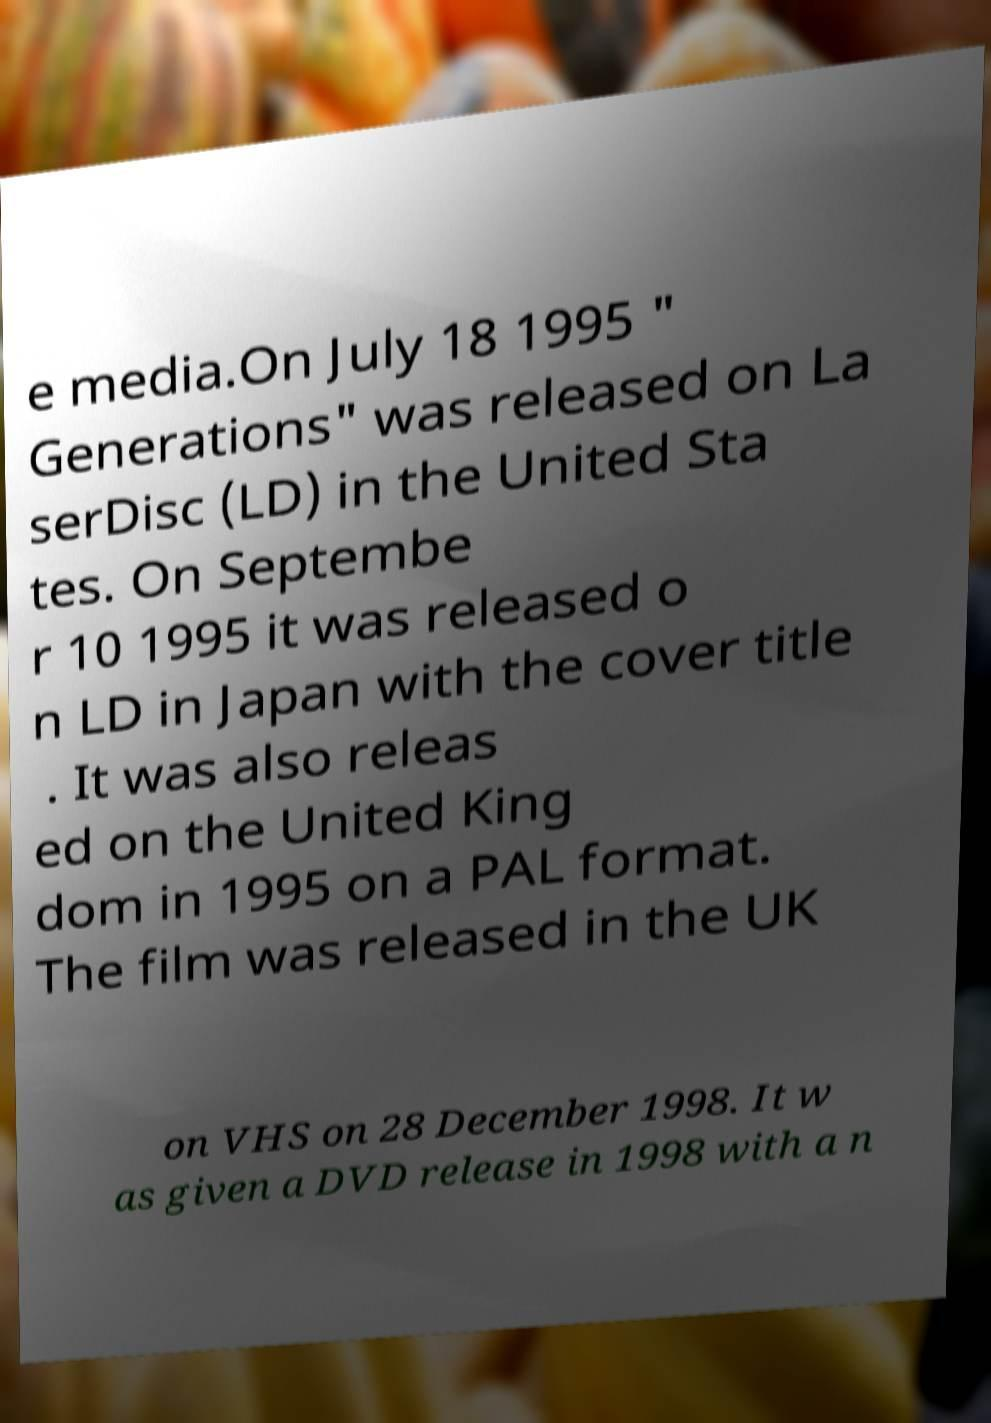Could you extract and type out the text from this image? e media.On July 18 1995 " Generations" was released on La serDisc (LD) in the United Sta tes. On Septembe r 10 1995 it was released o n LD in Japan with the cover title . It was also releas ed on the United King dom in 1995 on a PAL format. The film was released in the UK on VHS on 28 December 1998. It w as given a DVD release in 1998 with a n 